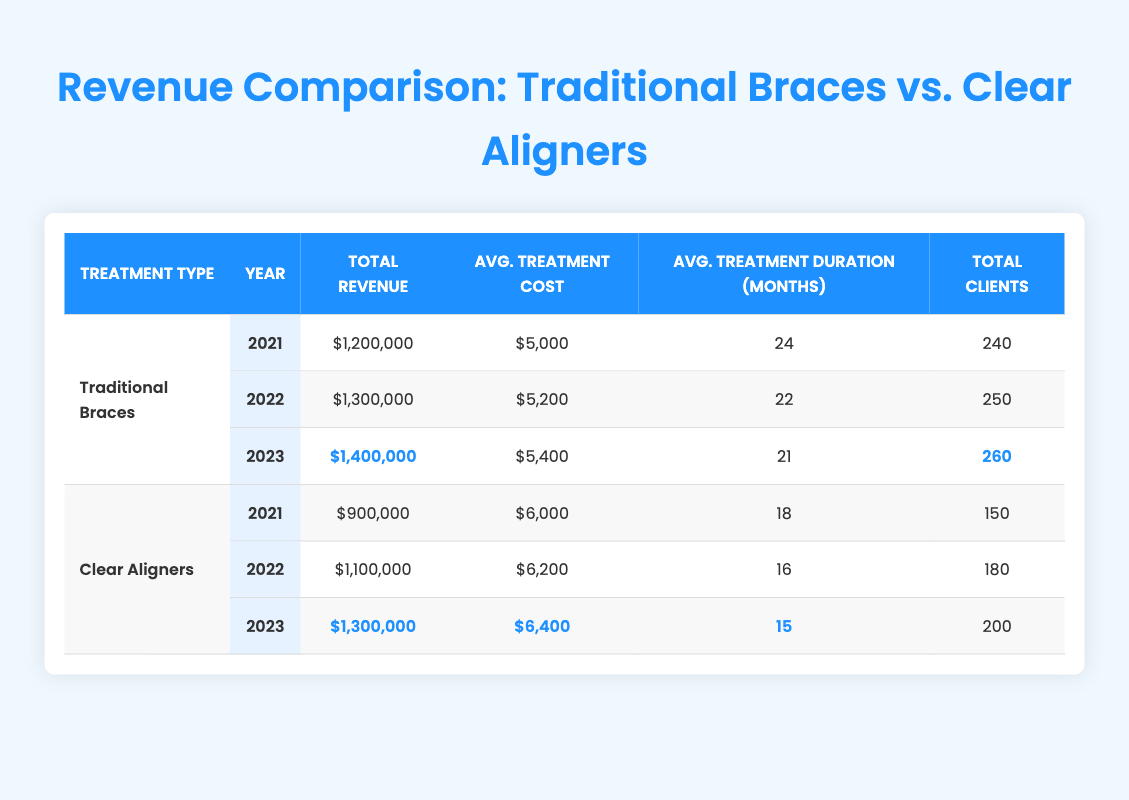What was the total revenue for Traditional Braces in 2022? According to the table, the total revenue for Traditional Braces in 2022 is listed as $1,300,000.
Answer: $1,300,000 What is the average treatment cost for Clear Aligners in 2023? The average treatment cost for Clear Aligners in 2023, as per the table, is $6,400.
Answer: $6,400 How many clients did Traditional Braces serve in 2021 compared to Clear Aligners? The table shows that Traditional Braces had 240 clients in 2021 while Clear Aligners had 150 clients in the same year.
Answer: Traditional Braces served 90 more clients What is the percentage increase in total revenue for Traditional Braces from 2021 to 2023? The total revenue for Traditional Braces increased from $1,200,000 in 2021 to $1,400,000 in 2023. The change is $1,400,000 - $1,200,000 = $200,000. The percentage increase can be calculated as ($200,000 / $1,200,000) * 100 = 16.67%.
Answer: 16.67% Did Clear Aligners have a higher average treatment duration than Traditional Braces in 2022? In 2022, the average treatment duration for Traditional Braces is 22 months, while for Clear Aligners it is 16 months. Since 22 months is greater than 16 months, the statement is true.
Answer: Yes What was the total revenue difference between the two treatments in 2023? In 2023, Traditional Braces had a total revenue of $1,400,000 and Clear Aligners had $1,300,000. The revenue difference is $1,400,000 - $1,300,000 = $100,000.
Answer: $100,000 What is the average treatment cost for both treatments over the three years? Sum the average treatment costs: Traditional Braces ($5,000 + $5,200 + $5,400) = $15,600; Clear Aligners ($6,000 + $6,200 + $6,400) = $18,600. Average for Traditional Braces is $15,600 / 3 = $5,200 and for Clear Aligners is $18,600 / 3 = $6,200.
Answer: Traditional Braces: $5,200; Clear Aligners: $6,200 Which treatment had a lower average treatment cost in 2021? The average treatment cost for Traditional Braces in 2021 is $5,000 and for Clear Aligners, it is $6,000. Comparing these values shows that $5,000 is lower than $6,000.
Answer: Traditional Braces had a lower average treatment cost In which year did Traditional Braces see the highest number of clients? The table shows that Traditional Braces had 240 clients in 2021, 250 in 2022, and 260 in 2023. Therefore, 260 clients in 2023 is the highest.
Answer: 2023 What is the trend in total revenue for Clear Aligners from 2021 to 2023? The revenue for Clear Aligners increased from $900,000 in 2021 to $1,100,000 in 2022, and further to $1,300,000 in 2023. This indicates a steady increase year over year.
Answer: The trend is increasing How much did the average treatment durations for both treatments decrease over the years? Traditional Braces decreased from 24 months in 2021 to 21 months in 2023 (a decrease of 3 months). Clear Aligners decreased from 18 months in 2021 to 15 months in 2023 (a decrease of 3 months). Both treatments decreased by the same amount.
Answer: Both decreased by 3 months 